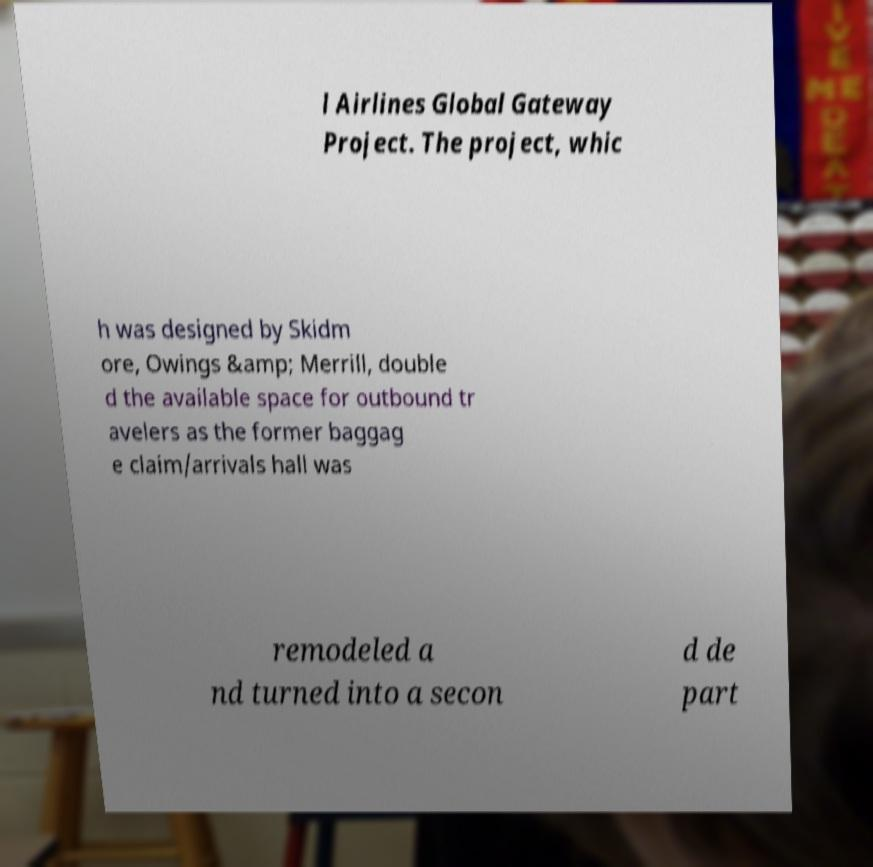Can you read and provide the text displayed in the image?This photo seems to have some interesting text. Can you extract and type it out for me? l Airlines Global Gateway Project. The project, whic h was designed by Skidm ore, Owings &amp; Merrill, double d the available space for outbound tr avelers as the former baggag e claim/arrivals hall was remodeled a nd turned into a secon d de part 